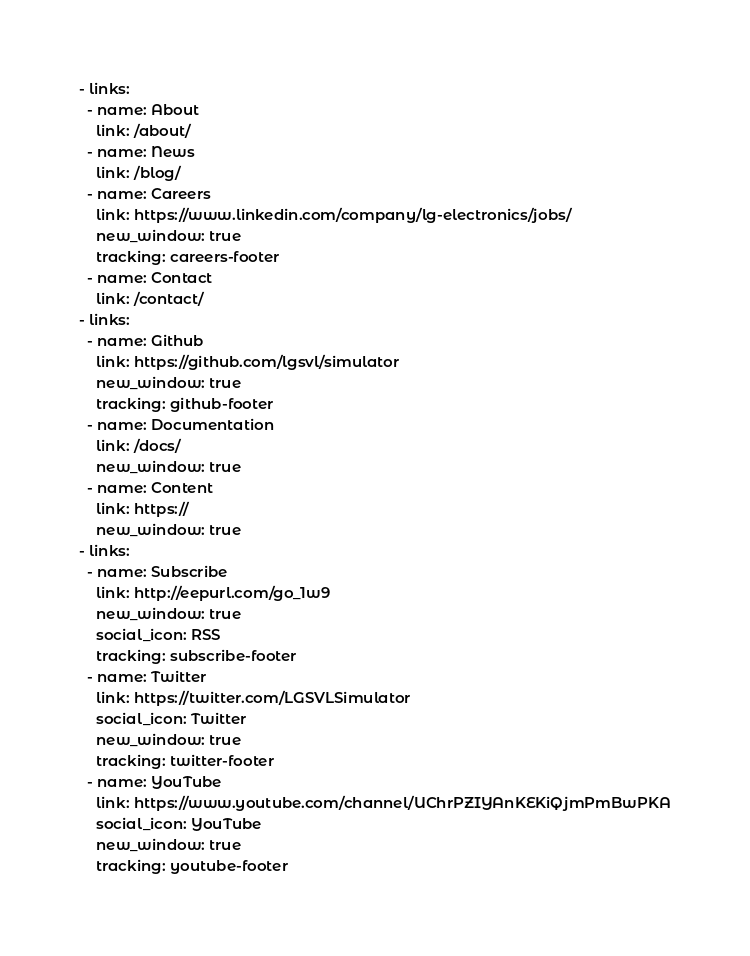<code> <loc_0><loc_0><loc_500><loc_500><_YAML_>- links:
  - name: About
    link: /about/
  - name: News
    link: /blog/
  - name: Careers
    link: https://www.linkedin.com/company/lg-electronics/jobs/
    new_window: true
    tracking: careers-footer
  - name: Contact
    link: /contact/
- links:
  - name: Github
    link: https://github.com/lgsvl/simulator
    new_window: true
    tracking: github-footer
  - name: Documentation
    link: /docs/
    new_window: true
  - name: Content
    link: https://
    new_window: true
- links:
  - name: Subscribe
    link: http://eepurl.com/go_1w9
    new_window: true
    social_icon: RSS
    tracking: subscribe-footer
  - name: Twitter
    link: https://twitter.com/LGSVLSimulator
    social_icon: Twitter
    new_window: true
    tracking: twitter-footer
  - name: YouTube
    link: https://www.youtube.com/channel/UChrPZIYAnKEKiQjmPmBwPKA
    social_icon: YouTube
    new_window: true
    tracking: youtube-footer
</code> 